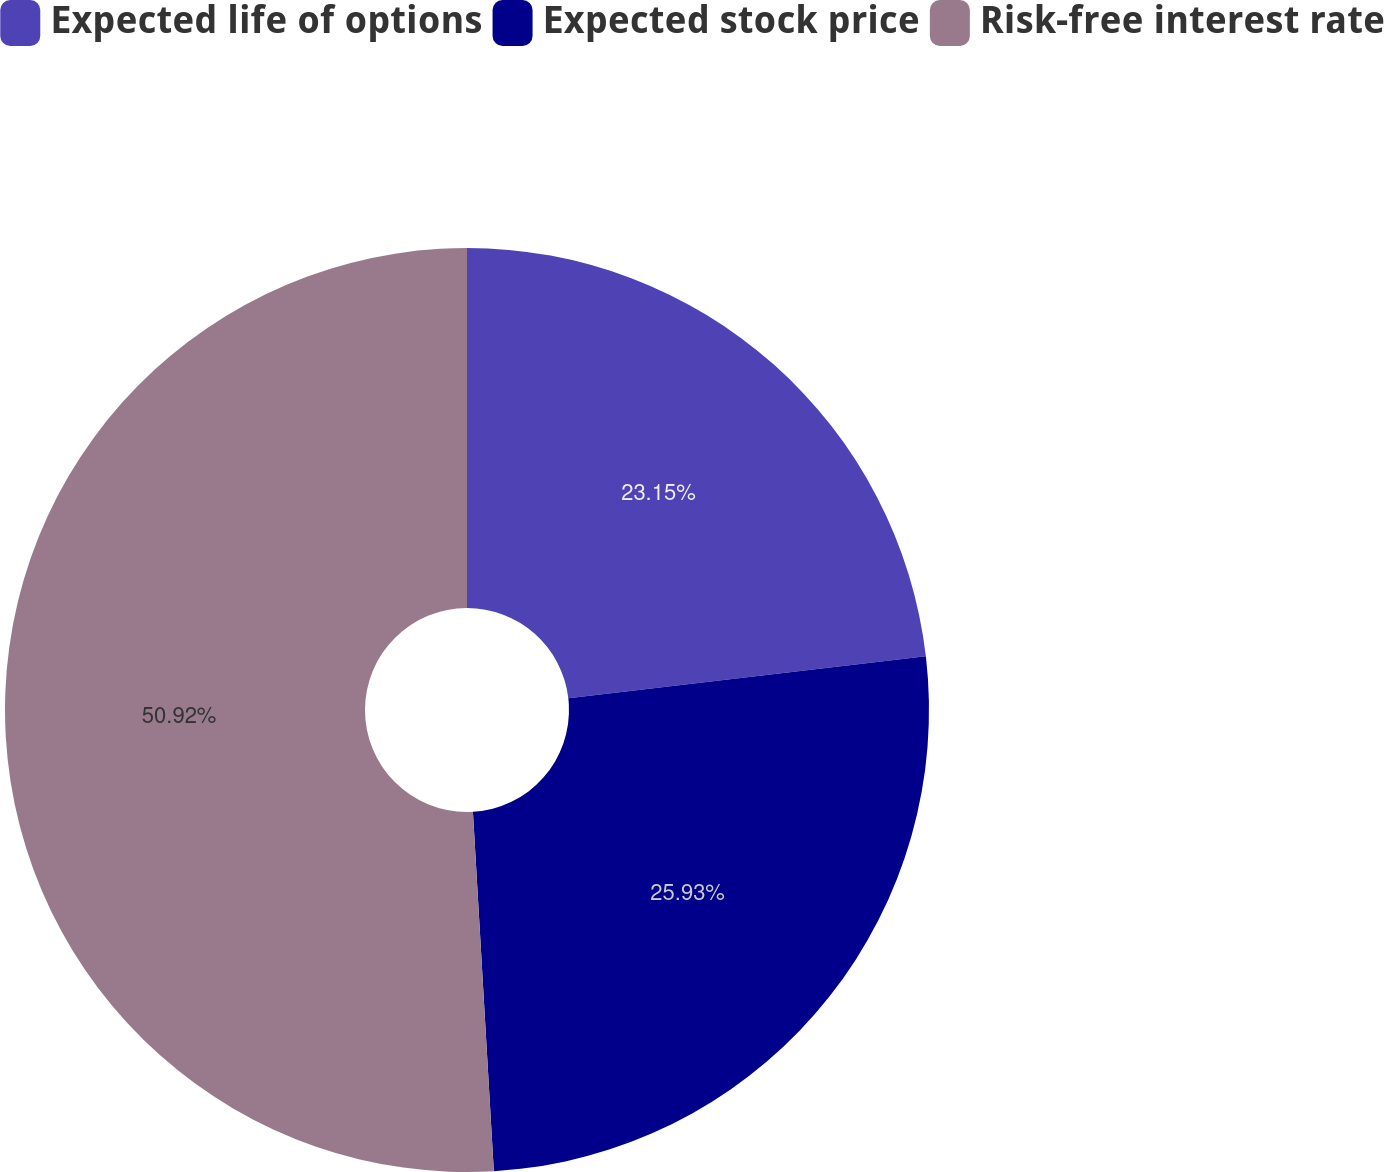Convert chart to OTSL. <chart><loc_0><loc_0><loc_500><loc_500><pie_chart><fcel>Expected life of options<fcel>Expected stock price<fcel>Risk-free interest rate<nl><fcel>23.15%<fcel>25.93%<fcel>50.93%<nl></chart> 